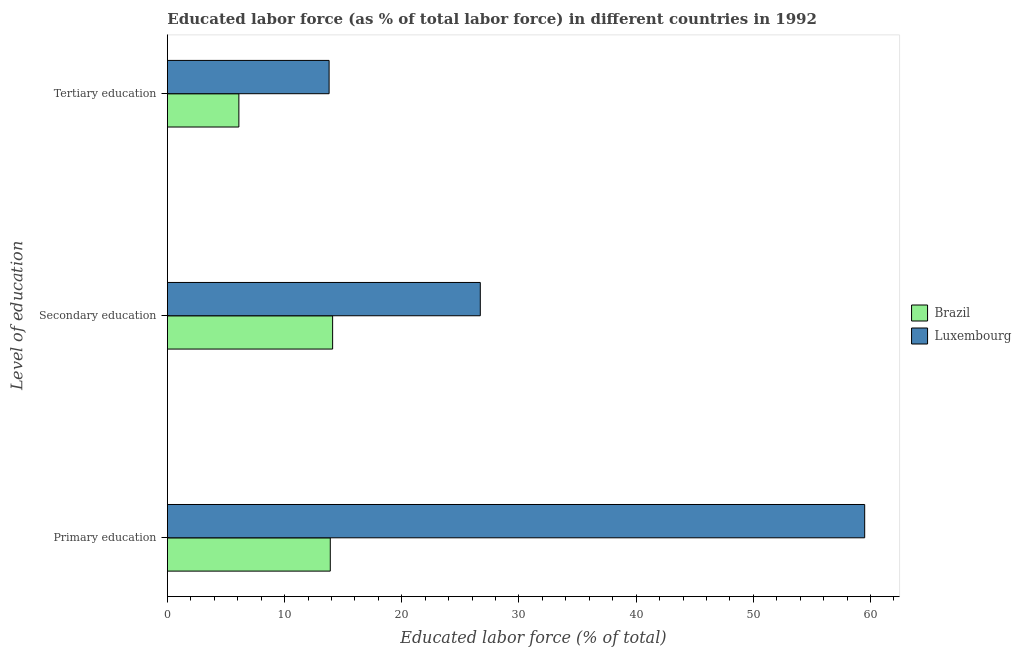Are the number of bars per tick equal to the number of legend labels?
Your response must be concise. Yes. Are the number of bars on each tick of the Y-axis equal?
Give a very brief answer. Yes. How many bars are there on the 2nd tick from the top?
Offer a terse response. 2. How many bars are there on the 3rd tick from the bottom?
Ensure brevity in your answer.  2. What is the label of the 3rd group of bars from the top?
Ensure brevity in your answer.  Primary education. What is the percentage of labor force who received tertiary education in Brazil?
Offer a terse response. 6.1. Across all countries, what is the maximum percentage of labor force who received secondary education?
Make the answer very short. 26.7. Across all countries, what is the minimum percentage of labor force who received tertiary education?
Your response must be concise. 6.1. In which country was the percentage of labor force who received secondary education maximum?
Make the answer very short. Luxembourg. What is the total percentage of labor force who received primary education in the graph?
Your response must be concise. 73.4. What is the difference between the percentage of labor force who received secondary education in Luxembourg and that in Brazil?
Offer a very short reply. 12.6. What is the difference between the percentage of labor force who received primary education in Brazil and the percentage of labor force who received secondary education in Luxembourg?
Keep it short and to the point. -12.8. What is the average percentage of labor force who received tertiary education per country?
Offer a very short reply. 9.95. What is the difference between the percentage of labor force who received tertiary education and percentage of labor force who received primary education in Brazil?
Ensure brevity in your answer.  -7.8. What is the ratio of the percentage of labor force who received secondary education in Brazil to that in Luxembourg?
Offer a terse response. 0.53. What is the difference between the highest and the second highest percentage of labor force who received primary education?
Make the answer very short. 45.6. What is the difference between the highest and the lowest percentage of labor force who received primary education?
Your answer should be compact. 45.6. Is the sum of the percentage of labor force who received secondary education in Luxembourg and Brazil greater than the maximum percentage of labor force who received tertiary education across all countries?
Provide a short and direct response. Yes. What does the 2nd bar from the top in Tertiary education represents?
Keep it short and to the point. Brazil. What does the 2nd bar from the bottom in Secondary education represents?
Make the answer very short. Luxembourg. How many countries are there in the graph?
Offer a very short reply. 2. Are the values on the major ticks of X-axis written in scientific E-notation?
Give a very brief answer. No. Does the graph contain any zero values?
Ensure brevity in your answer.  No. How are the legend labels stacked?
Offer a very short reply. Vertical. What is the title of the graph?
Ensure brevity in your answer.  Educated labor force (as % of total labor force) in different countries in 1992. What is the label or title of the X-axis?
Offer a terse response. Educated labor force (% of total). What is the label or title of the Y-axis?
Your answer should be very brief. Level of education. What is the Educated labor force (% of total) in Brazil in Primary education?
Offer a very short reply. 13.9. What is the Educated labor force (% of total) of Luxembourg in Primary education?
Offer a very short reply. 59.5. What is the Educated labor force (% of total) in Brazil in Secondary education?
Give a very brief answer. 14.1. What is the Educated labor force (% of total) in Luxembourg in Secondary education?
Make the answer very short. 26.7. What is the Educated labor force (% of total) in Brazil in Tertiary education?
Offer a very short reply. 6.1. What is the Educated labor force (% of total) in Luxembourg in Tertiary education?
Keep it short and to the point. 13.8. Across all Level of education, what is the maximum Educated labor force (% of total) of Brazil?
Your answer should be compact. 14.1. Across all Level of education, what is the maximum Educated labor force (% of total) in Luxembourg?
Give a very brief answer. 59.5. Across all Level of education, what is the minimum Educated labor force (% of total) in Brazil?
Offer a very short reply. 6.1. Across all Level of education, what is the minimum Educated labor force (% of total) of Luxembourg?
Your response must be concise. 13.8. What is the total Educated labor force (% of total) in Brazil in the graph?
Ensure brevity in your answer.  34.1. What is the difference between the Educated labor force (% of total) in Brazil in Primary education and that in Secondary education?
Give a very brief answer. -0.2. What is the difference between the Educated labor force (% of total) of Luxembourg in Primary education and that in Secondary education?
Offer a terse response. 32.8. What is the difference between the Educated labor force (% of total) of Luxembourg in Primary education and that in Tertiary education?
Give a very brief answer. 45.7. What is the difference between the Educated labor force (% of total) of Brazil in Secondary education and that in Tertiary education?
Your answer should be very brief. 8. What is the difference between the Educated labor force (% of total) in Brazil in Primary education and the Educated labor force (% of total) in Luxembourg in Secondary education?
Offer a very short reply. -12.8. What is the average Educated labor force (% of total) in Brazil per Level of education?
Keep it short and to the point. 11.37. What is the average Educated labor force (% of total) of Luxembourg per Level of education?
Keep it short and to the point. 33.33. What is the difference between the Educated labor force (% of total) in Brazil and Educated labor force (% of total) in Luxembourg in Primary education?
Your answer should be very brief. -45.6. What is the ratio of the Educated labor force (% of total) in Brazil in Primary education to that in Secondary education?
Keep it short and to the point. 0.99. What is the ratio of the Educated labor force (% of total) of Luxembourg in Primary education to that in Secondary education?
Your response must be concise. 2.23. What is the ratio of the Educated labor force (% of total) in Brazil in Primary education to that in Tertiary education?
Keep it short and to the point. 2.28. What is the ratio of the Educated labor force (% of total) of Luxembourg in Primary education to that in Tertiary education?
Your response must be concise. 4.31. What is the ratio of the Educated labor force (% of total) of Brazil in Secondary education to that in Tertiary education?
Keep it short and to the point. 2.31. What is the ratio of the Educated labor force (% of total) of Luxembourg in Secondary education to that in Tertiary education?
Your response must be concise. 1.93. What is the difference between the highest and the second highest Educated labor force (% of total) in Luxembourg?
Your response must be concise. 32.8. What is the difference between the highest and the lowest Educated labor force (% of total) in Luxembourg?
Offer a terse response. 45.7. 